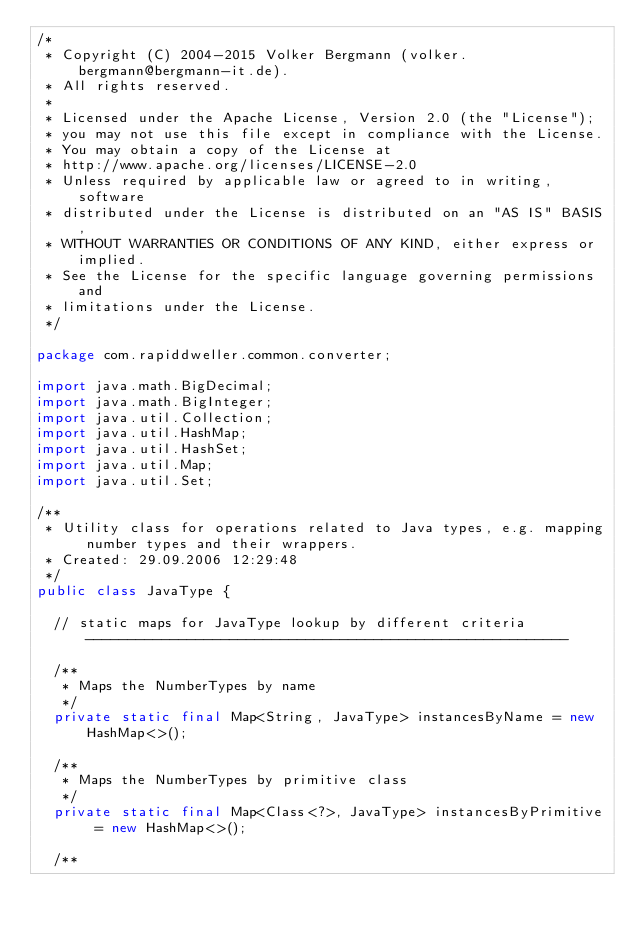Convert code to text. <code><loc_0><loc_0><loc_500><loc_500><_Java_>/*
 * Copyright (C) 2004-2015 Volker Bergmann (volker.bergmann@bergmann-it.de).
 * All rights reserved.
 *
 * Licensed under the Apache License, Version 2.0 (the "License");
 * you may not use this file except in compliance with the License.
 * You may obtain a copy of the License at
 * http://www.apache.org/licenses/LICENSE-2.0
 * Unless required by applicable law or agreed to in writing, software
 * distributed under the License is distributed on an "AS IS" BASIS,
 * WITHOUT WARRANTIES OR CONDITIONS OF ANY KIND, either express or implied.
 * See the License for the specific language governing permissions and
 * limitations under the License.
 */

package com.rapiddweller.common.converter;

import java.math.BigDecimal;
import java.math.BigInteger;
import java.util.Collection;
import java.util.HashMap;
import java.util.HashSet;
import java.util.Map;
import java.util.Set;

/**
 * Utility class for operations related to Java types, e.g. mapping number types and their wrappers.
 * Created: 29.09.2006 12:29:48
 */
public class JavaType {

  // static maps for JavaType lookup by different criteria ---------------------------------------------------------

  /**
   * Maps the NumberTypes by name
   */
  private static final Map<String, JavaType> instancesByName = new HashMap<>();

  /**
   * Maps the NumberTypes by primitive class
   */
  private static final Map<Class<?>, JavaType> instancesByPrimitive = new HashMap<>();

  /**</code> 